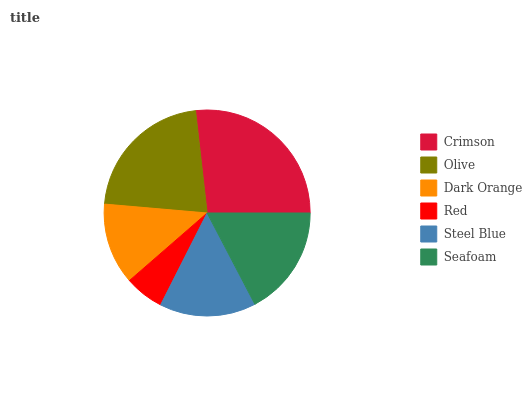Is Red the minimum?
Answer yes or no. Yes. Is Crimson the maximum?
Answer yes or no. Yes. Is Olive the minimum?
Answer yes or no. No. Is Olive the maximum?
Answer yes or no. No. Is Crimson greater than Olive?
Answer yes or no. Yes. Is Olive less than Crimson?
Answer yes or no. Yes. Is Olive greater than Crimson?
Answer yes or no. No. Is Crimson less than Olive?
Answer yes or no. No. Is Seafoam the high median?
Answer yes or no. Yes. Is Steel Blue the low median?
Answer yes or no. Yes. Is Steel Blue the high median?
Answer yes or no. No. Is Olive the low median?
Answer yes or no. No. 